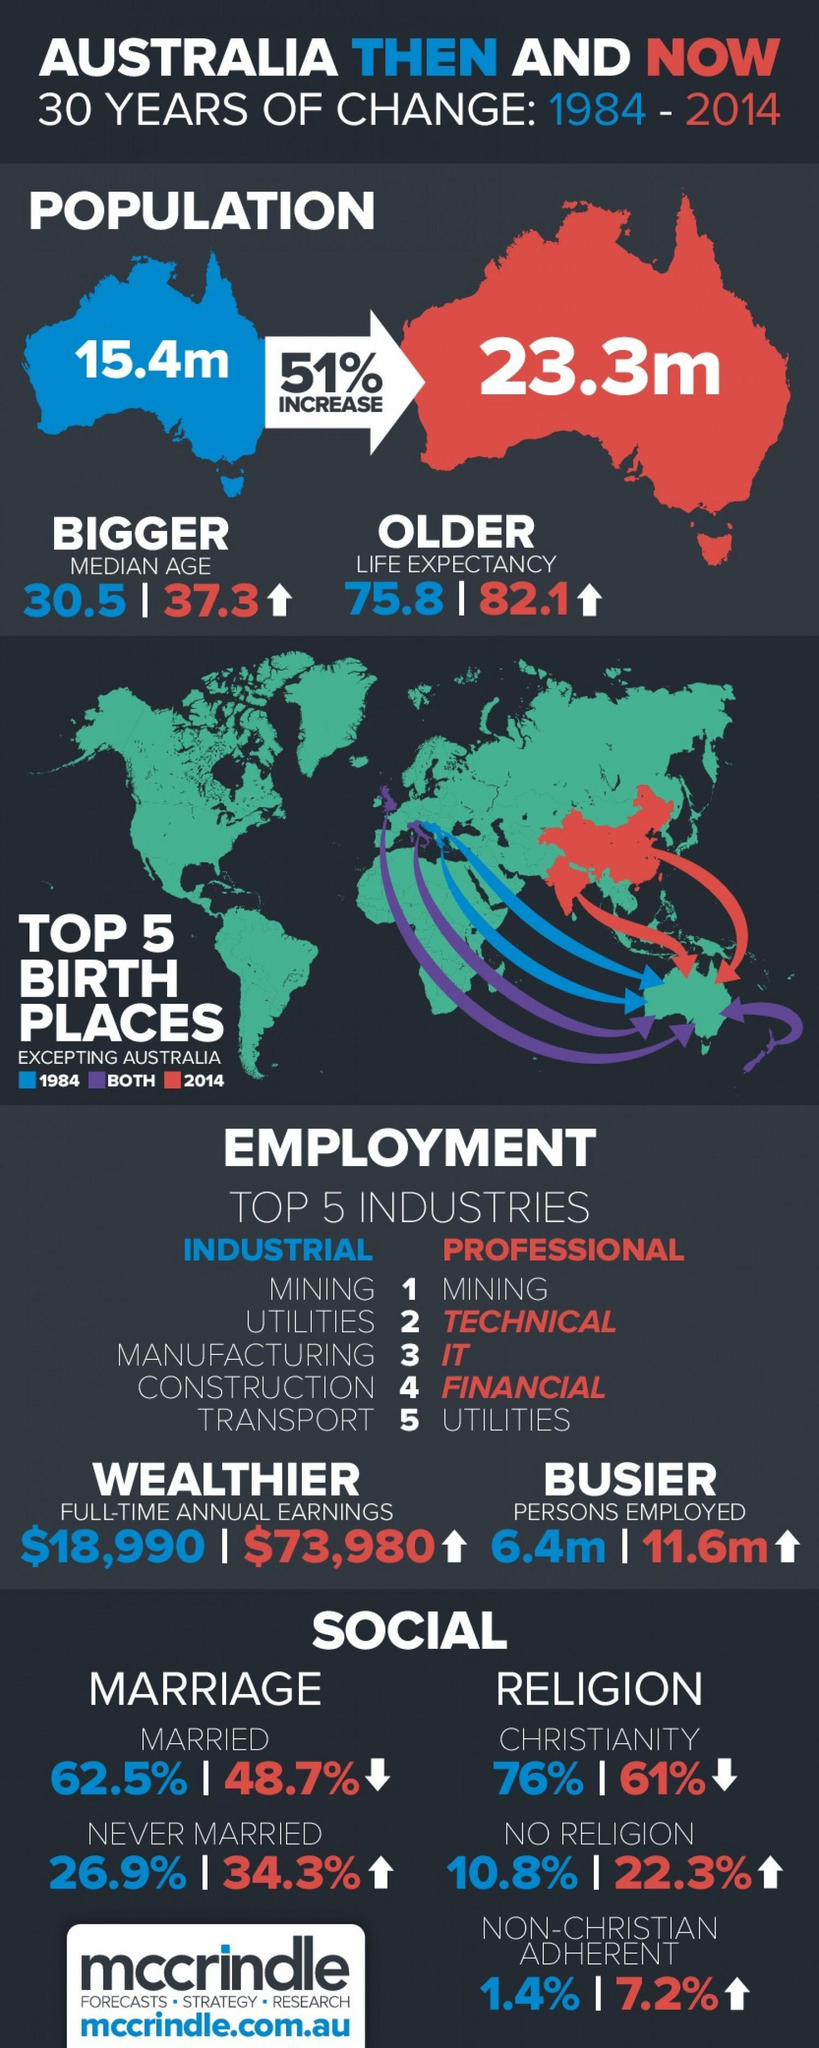How many Australians followed no religion in the year 2014?
Answer the question with a short phrase. 22.3% What percentage of Australians was never married in the year 2014? 34.3% What percentage of Australians got married in the year 2014? 48.7% How many more Australians were employed in the year 2014 when compared to 1984? 5.2 What is the population of Australia in 2014? 23.3m What is the life expectancy rate of Australians in the year 1984? 75.8 How many Australians followed no religion in the year 1984? 10.8% What is the difference in median age between the year 1984 and 2014? 6.8 In which year Australia has better Life Expectancy? 2014 How much is the decrease in percentage of Christians in the year 2014 when compared to 1984? 15 